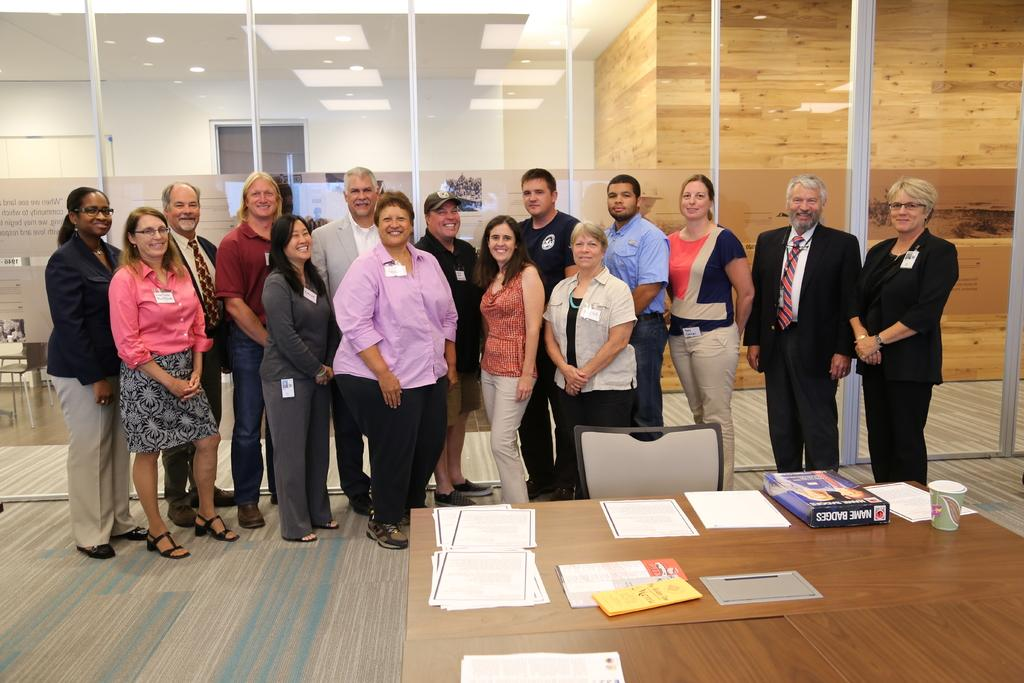Who or what is present in the image? There are people in the image. What are the people doing in the image? The people are standing. What object can be seen in the image besides the people? There is a table in the image. What is on the table in the image? There are papers on the table. What type of body is visible in the image? There is no body present in the image; it features people standing and a table with papers. What is the answer to the question that is being asked in the image? There is no question being asked in the image, so there is no answer to provide. 